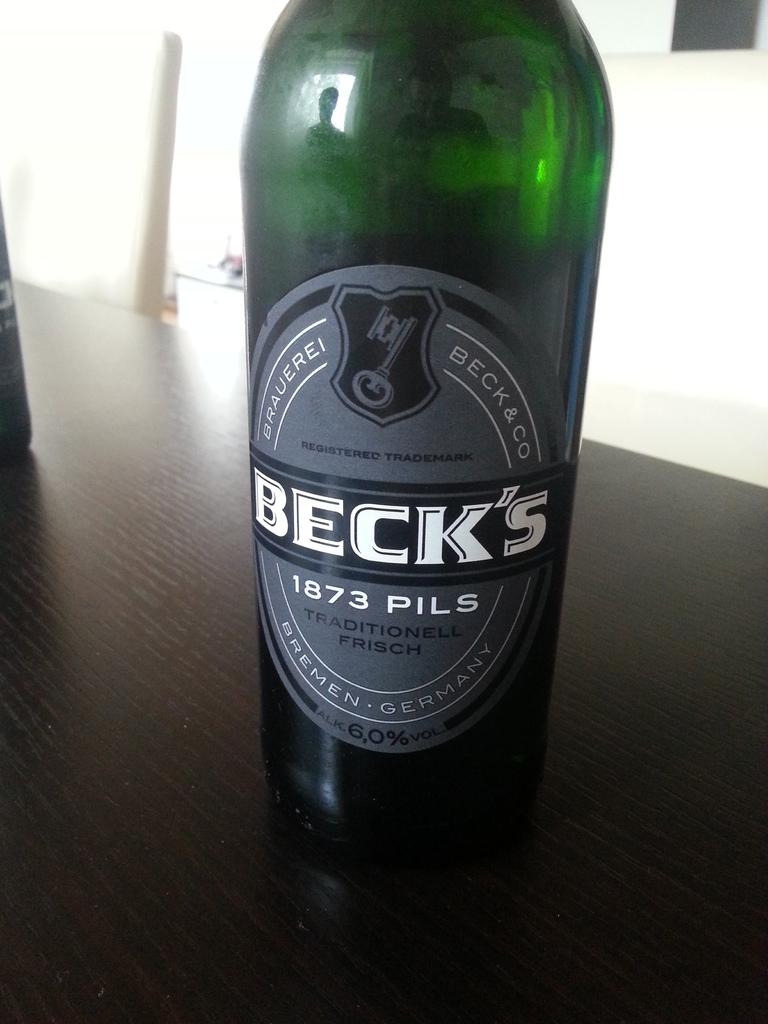<image>
Give a short and clear explanation of the subsequent image. A bottle of Beck's 1873 Pils Traditionell Frisch from Bremen, Germany 